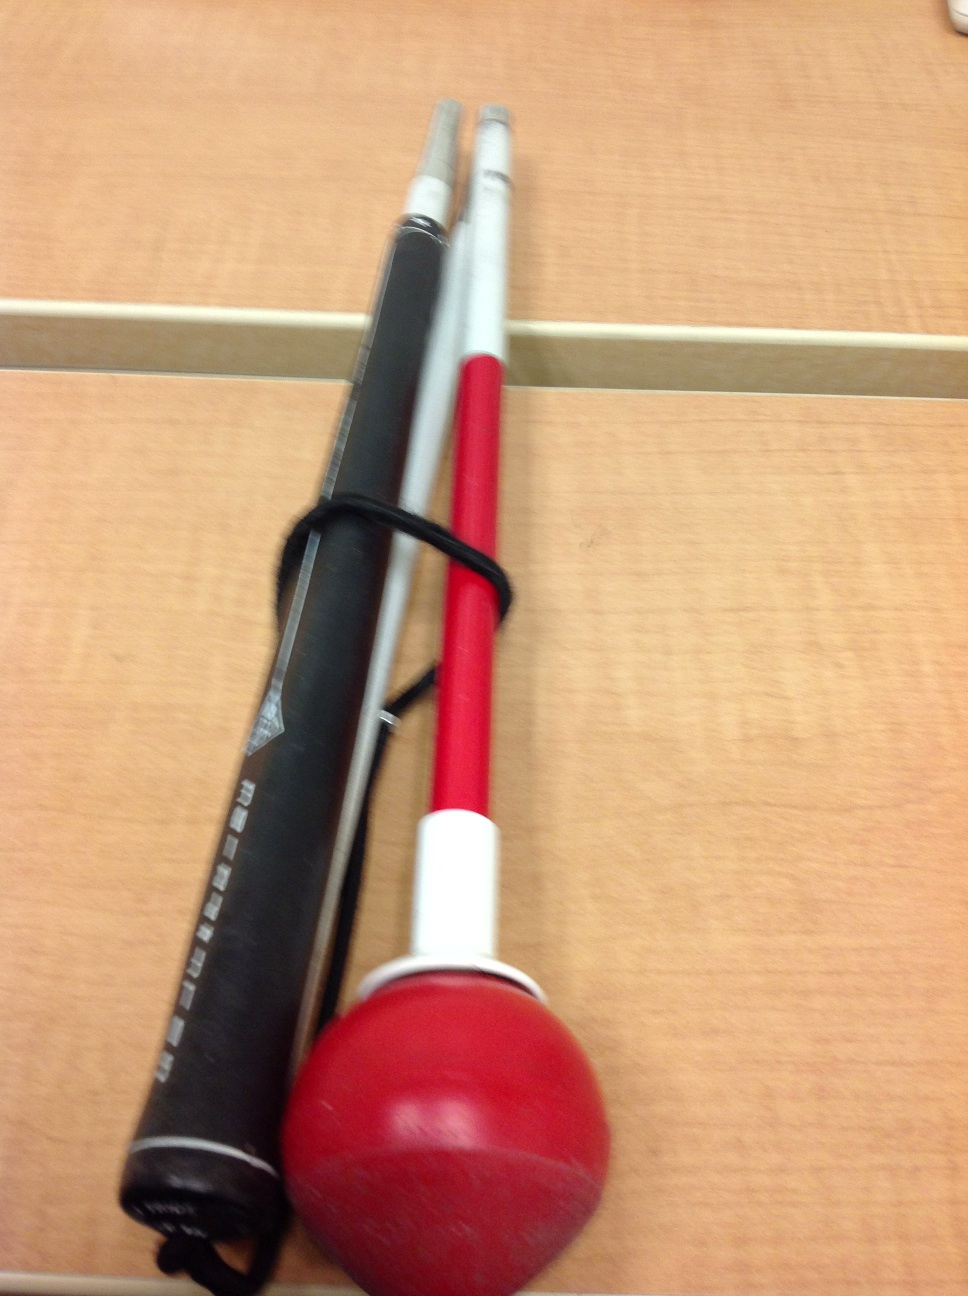Could you give me more details on how this training device works? Certainly! This type of swing trainer usually consists of a weighted ball attached to the bat with flexible rods. When a batter swings the bat, the ball provides resistance and feedback through the rods, helping refine muscle memory for a smoother, more powerful swing. Is it suitable for all ages? Yes, swing trainers like this one are typically adjustable and can be used by players of various age groups and skill levels, from young beginners to experienced adults. 